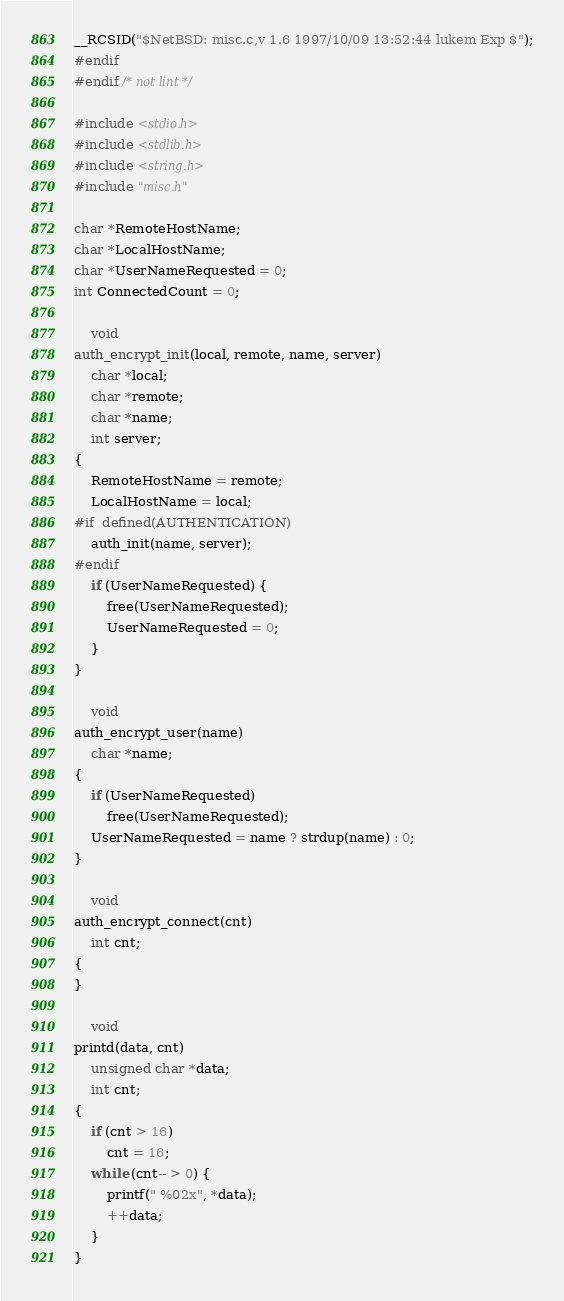<code> <loc_0><loc_0><loc_500><loc_500><_C_>__RCSID("$NetBSD: misc.c,v 1.6 1997/10/09 13:52:44 lukem Exp $");
#endif
#endif /* not lint */

#include <stdio.h>
#include <stdlib.h>
#include <string.h>
#include "misc.h"

char *RemoteHostName;
char *LocalHostName;
char *UserNameRequested = 0;
int ConnectedCount = 0;

	void
auth_encrypt_init(local, remote, name, server)
	char *local;
	char *remote;
	char *name;
	int server;
{
	RemoteHostName = remote;
	LocalHostName = local;
#if	defined(AUTHENTICATION)
	auth_init(name, server);
#endif
	if (UserNameRequested) {
		free(UserNameRequested);
		UserNameRequested = 0;
	}
}

	void
auth_encrypt_user(name)
	char *name;
{
	if (UserNameRequested)
		free(UserNameRequested);
	UserNameRequested = name ? strdup(name) : 0;
}

	void
auth_encrypt_connect(cnt)
	int cnt;
{
}

	void
printd(data, cnt)
	unsigned char *data;
	int cnt;
{
	if (cnt > 16)
		cnt = 16;
	while (cnt-- > 0) {
		printf(" %02x", *data);
		++data;
	}
}
</code> 